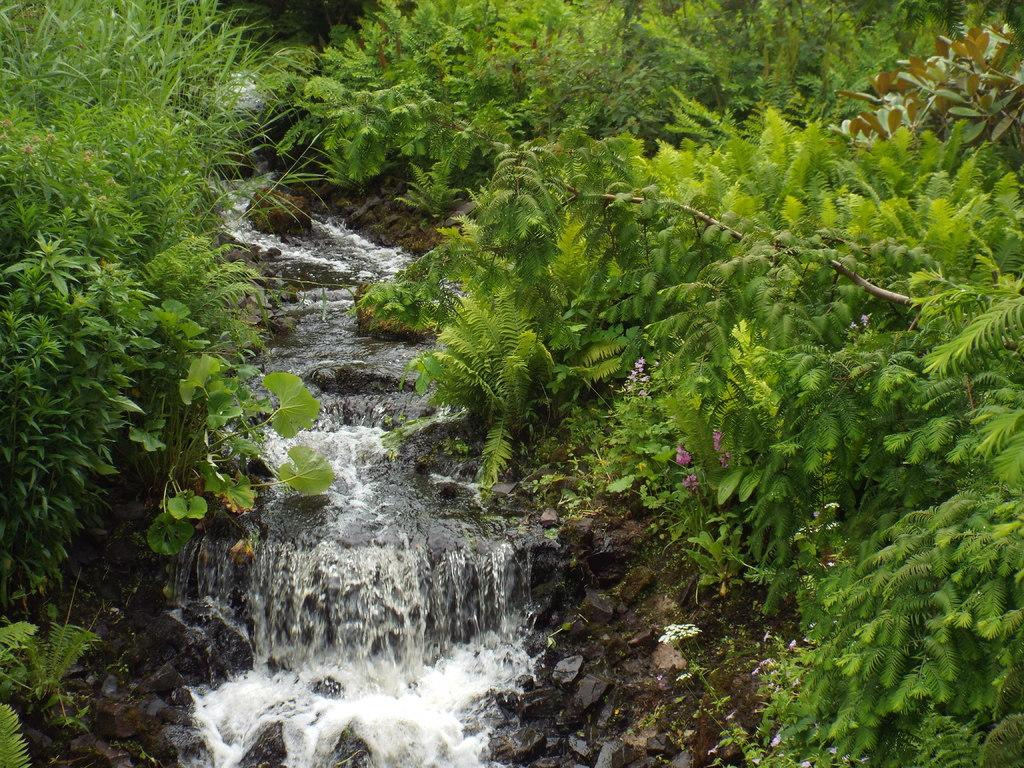What is visible in the image? Water, green trees, and flowers are visible in the image. Can you describe the trees in the image? The trees in the image are green. What type of flora is present in the image? Flowers are present in the image. What is the name of the daughter who is playing with the butter in the image? There is no daughter or butter present in the image. What route is visible in the image? There is no route visible in the image. 